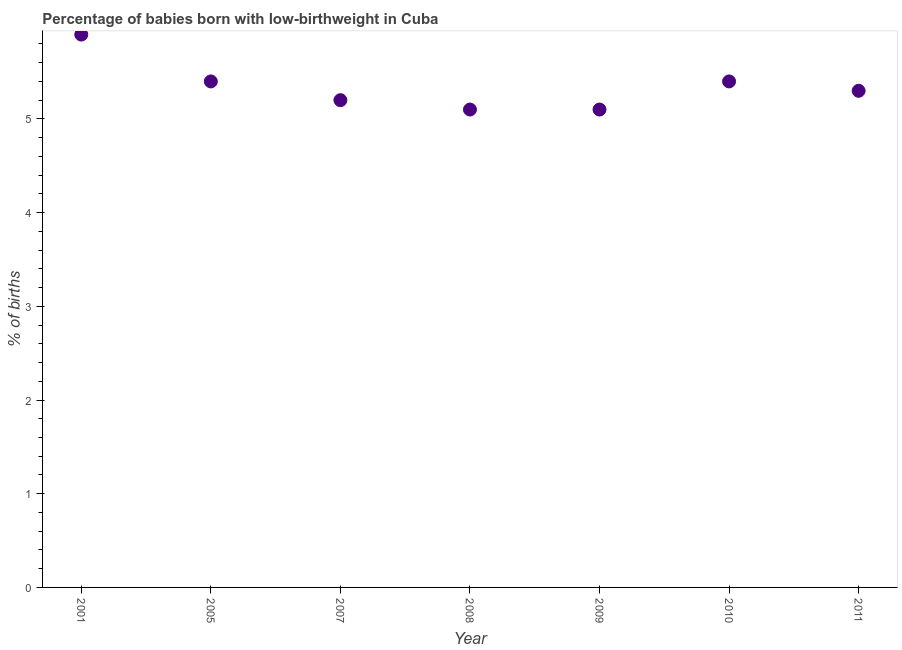What is the percentage of babies who were born with low-birthweight in 2011?
Offer a very short reply. 5.3. What is the sum of the percentage of babies who were born with low-birthweight?
Ensure brevity in your answer.  37.4. What is the difference between the percentage of babies who were born with low-birthweight in 2007 and 2008?
Your answer should be compact. 0.1. What is the average percentage of babies who were born with low-birthweight per year?
Make the answer very short. 5.34. In how many years, is the percentage of babies who were born with low-birthweight greater than 2.8 %?
Ensure brevity in your answer.  7. Do a majority of the years between 2009 and 2011 (inclusive) have percentage of babies who were born with low-birthweight greater than 4.4 %?
Provide a short and direct response. Yes. What is the ratio of the percentage of babies who were born with low-birthweight in 2005 to that in 2011?
Ensure brevity in your answer.  1.02. Is the percentage of babies who were born with low-birthweight in 2005 less than that in 2008?
Provide a short and direct response. No. Is the sum of the percentage of babies who were born with low-birthweight in 2005 and 2007 greater than the maximum percentage of babies who were born with low-birthweight across all years?
Your answer should be compact. Yes. What is the difference between the highest and the lowest percentage of babies who were born with low-birthweight?
Provide a succinct answer. 0.8. Does the percentage of babies who were born with low-birthweight monotonically increase over the years?
Your answer should be very brief. No. What is the difference between two consecutive major ticks on the Y-axis?
Your answer should be compact. 1. Are the values on the major ticks of Y-axis written in scientific E-notation?
Give a very brief answer. No. What is the title of the graph?
Provide a succinct answer. Percentage of babies born with low-birthweight in Cuba. What is the label or title of the X-axis?
Provide a short and direct response. Year. What is the label or title of the Y-axis?
Make the answer very short. % of births. What is the % of births in 2001?
Keep it short and to the point. 5.9. What is the % of births in 2005?
Make the answer very short. 5.4. What is the % of births in 2007?
Provide a succinct answer. 5.2. What is the % of births in 2010?
Ensure brevity in your answer.  5.4. What is the % of births in 2011?
Give a very brief answer. 5.3. What is the difference between the % of births in 2001 and 2007?
Ensure brevity in your answer.  0.7. What is the difference between the % of births in 2001 and 2011?
Give a very brief answer. 0.6. What is the difference between the % of births in 2005 and 2008?
Offer a terse response. 0.3. What is the difference between the % of births in 2005 and 2010?
Your answer should be compact. 0. What is the difference between the % of births in 2005 and 2011?
Make the answer very short. 0.1. What is the difference between the % of births in 2007 and 2008?
Provide a short and direct response. 0.1. What is the difference between the % of births in 2007 and 2010?
Your answer should be compact. -0.2. What is the difference between the % of births in 2007 and 2011?
Offer a very short reply. -0.1. What is the difference between the % of births in 2009 and 2010?
Give a very brief answer. -0.3. What is the difference between the % of births in 2009 and 2011?
Provide a succinct answer. -0.2. What is the difference between the % of births in 2010 and 2011?
Your answer should be compact. 0.1. What is the ratio of the % of births in 2001 to that in 2005?
Your response must be concise. 1.09. What is the ratio of the % of births in 2001 to that in 2007?
Offer a very short reply. 1.14. What is the ratio of the % of births in 2001 to that in 2008?
Keep it short and to the point. 1.16. What is the ratio of the % of births in 2001 to that in 2009?
Offer a very short reply. 1.16. What is the ratio of the % of births in 2001 to that in 2010?
Provide a succinct answer. 1.09. What is the ratio of the % of births in 2001 to that in 2011?
Offer a very short reply. 1.11. What is the ratio of the % of births in 2005 to that in 2007?
Provide a succinct answer. 1.04. What is the ratio of the % of births in 2005 to that in 2008?
Provide a succinct answer. 1.06. What is the ratio of the % of births in 2005 to that in 2009?
Your answer should be compact. 1.06. What is the ratio of the % of births in 2005 to that in 2010?
Your answer should be compact. 1. What is the ratio of the % of births in 2005 to that in 2011?
Your answer should be very brief. 1.02. What is the ratio of the % of births in 2007 to that in 2008?
Offer a very short reply. 1.02. What is the ratio of the % of births in 2007 to that in 2011?
Your answer should be compact. 0.98. What is the ratio of the % of births in 2008 to that in 2010?
Give a very brief answer. 0.94. What is the ratio of the % of births in 2008 to that in 2011?
Keep it short and to the point. 0.96. What is the ratio of the % of births in 2009 to that in 2010?
Your answer should be compact. 0.94. What is the ratio of the % of births in 2009 to that in 2011?
Provide a short and direct response. 0.96. What is the ratio of the % of births in 2010 to that in 2011?
Make the answer very short. 1.02. 